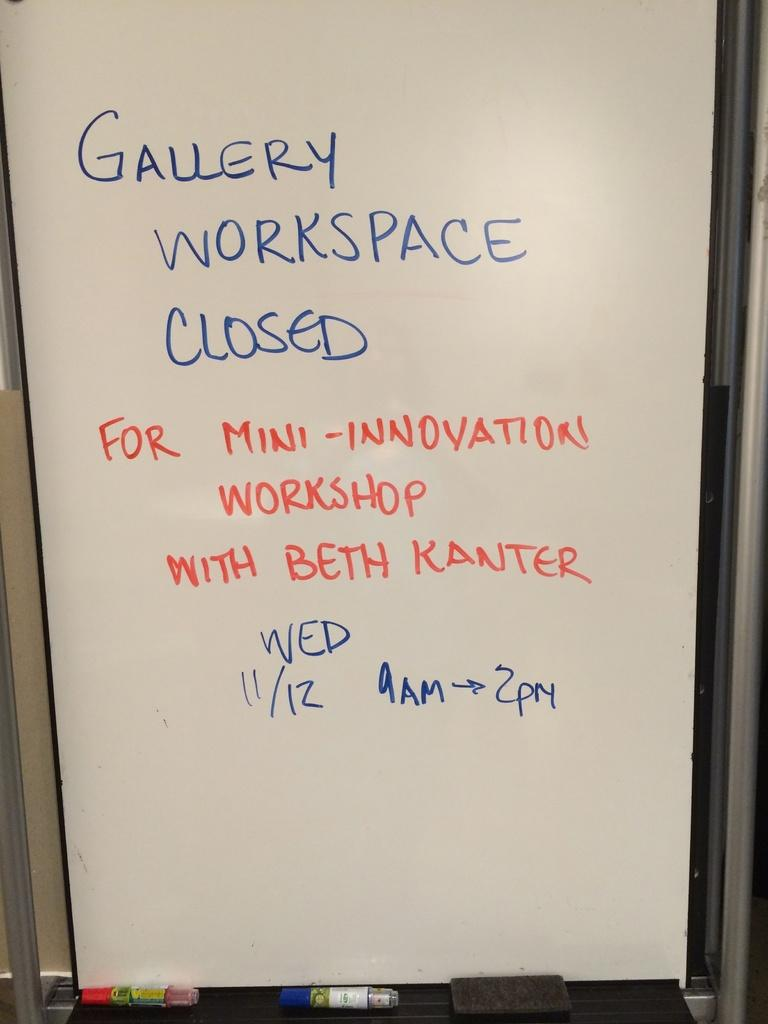<image>
Relay a brief, clear account of the picture shown. Gallery workspace closed written on a white board 